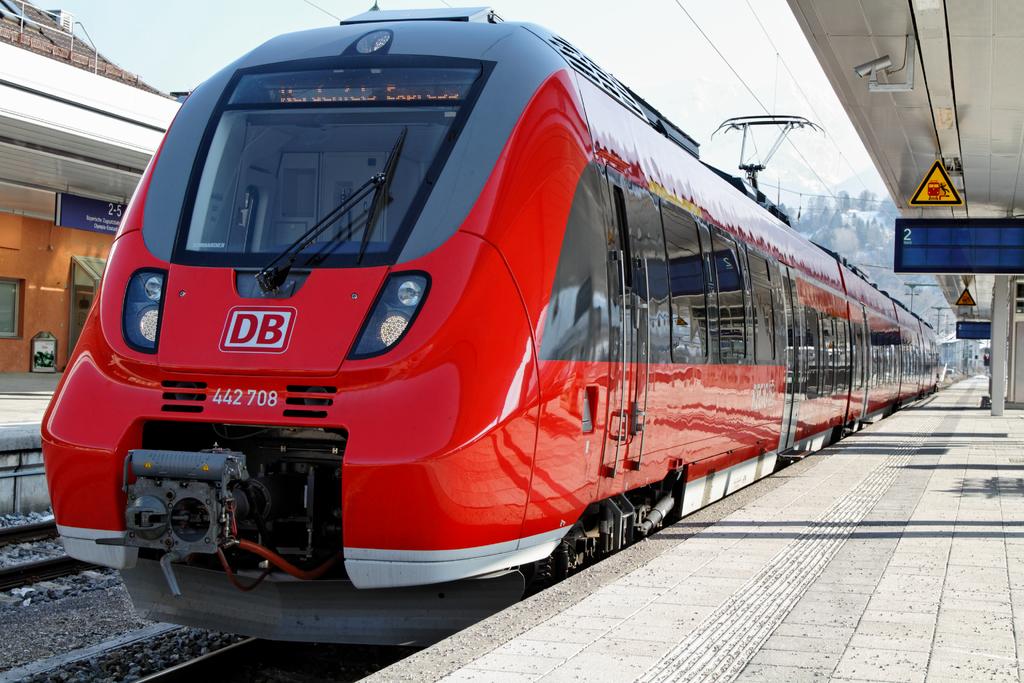What is the number on the front of this train?
Ensure brevity in your answer.  442708. Are the letters d and b on the front of this train?
Offer a very short reply. Yes. 